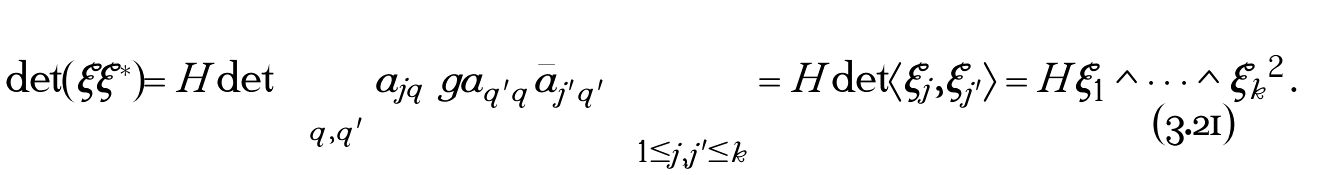Convert formula to latex. <formula><loc_0><loc_0><loc_500><loc_500>\det ( \xi \xi ^ { * } ) = H \det \left ( \sum _ { q , q ^ { \prime } } a _ { j q } \ g a _ { q ^ { \prime } q } \bar { a } _ { j ^ { \prime } q ^ { \prime } } \right ) _ { 1 \leq j , j ^ { \prime } \leq k } = H \det \langle \xi _ { j } , \xi _ { j ^ { \prime } } \rangle = H \| \xi _ { 1 } \wedge \dots \wedge \xi _ { k } \| ^ { 2 } \, .</formula> 